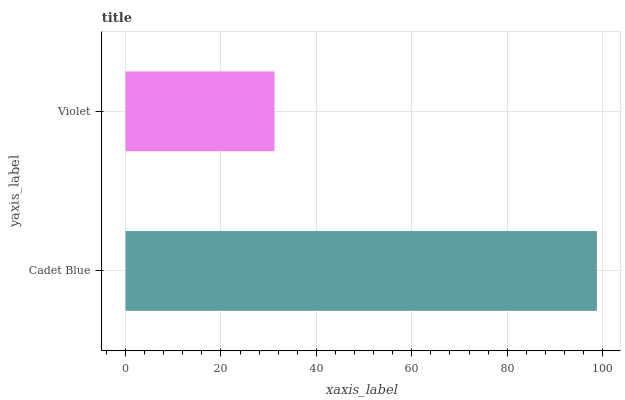Is Violet the minimum?
Answer yes or no. Yes. Is Cadet Blue the maximum?
Answer yes or no. Yes. Is Violet the maximum?
Answer yes or no. No. Is Cadet Blue greater than Violet?
Answer yes or no. Yes. Is Violet less than Cadet Blue?
Answer yes or no. Yes. Is Violet greater than Cadet Blue?
Answer yes or no. No. Is Cadet Blue less than Violet?
Answer yes or no. No. Is Cadet Blue the high median?
Answer yes or no. Yes. Is Violet the low median?
Answer yes or no. Yes. Is Violet the high median?
Answer yes or no. No. Is Cadet Blue the low median?
Answer yes or no. No. 